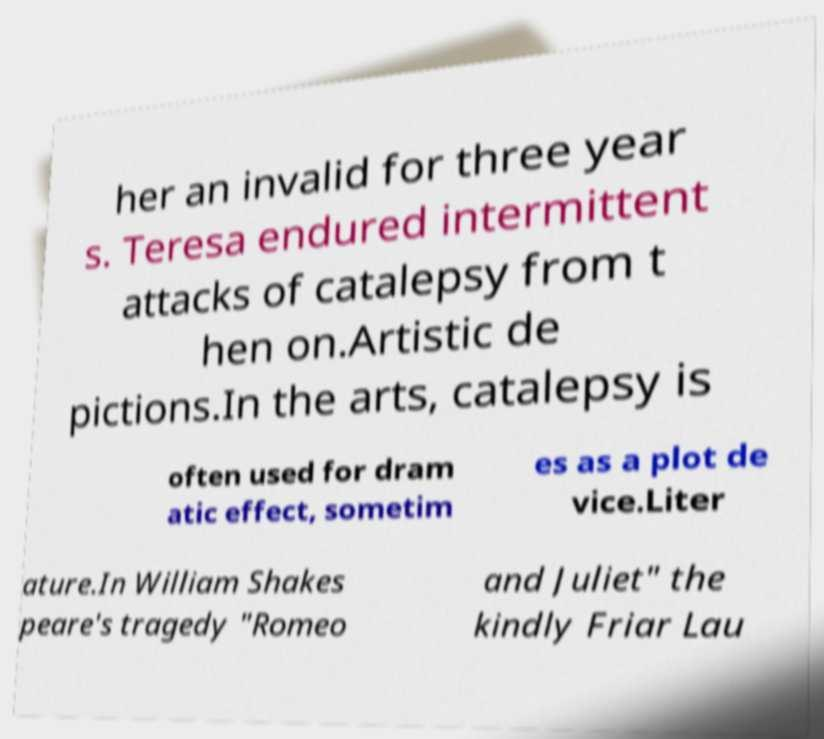Please identify and transcribe the text found in this image. her an invalid for three year s. Teresa endured intermittent attacks of catalepsy from t hen on.Artistic de pictions.In the arts, catalepsy is often used for dram atic effect, sometim es as a plot de vice.Liter ature.In William Shakes peare's tragedy "Romeo and Juliet" the kindly Friar Lau 